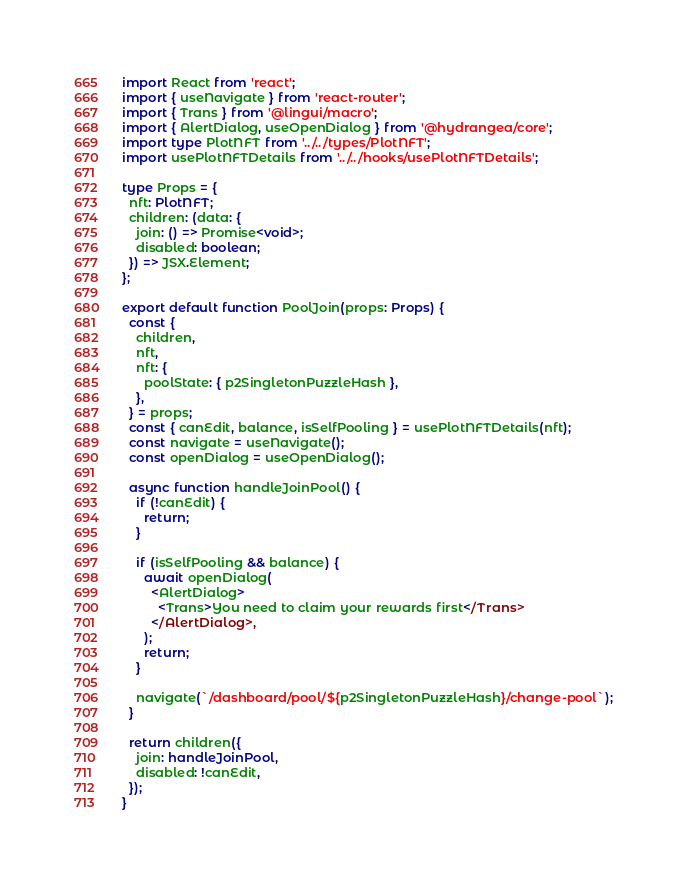<code> <loc_0><loc_0><loc_500><loc_500><_TypeScript_>import React from 'react';
import { useNavigate } from 'react-router';
import { Trans } from '@lingui/macro';
import { AlertDialog, useOpenDialog } from '@hydrangea/core';
import type PlotNFT from '../../types/PlotNFT';
import usePlotNFTDetails from '../../hooks/usePlotNFTDetails';

type Props = {
  nft: PlotNFT;
  children: (data: {
    join: () => Promise<void>;
    disabled: boolean;
  }) => JSX.Element;
};

export default function PoolJoin(props: Props) {
  const {
    children,
    nft,
    nft: {
      poolState: { p2SingletonPuzzleHash },
    },
  } = props;
  const { canEdit, balance, isSelfPooling } = usePlotNFTDetails(nft);
  const navigate = useNavigate();
  const openDialog = useOpenDialog();

  async function handleJoinPool() {
    if (!canEdit) {
      return;
    }

    if (isSelfPooling && balance) {
      await openDialog(
        <AlertDialog>
          <Trans>You need to claim your rewards first</Trans>
        </AlertDialog>,
      );
      return;
    }

    navigate(`/dashboard/pool/${p2SingletonPuzzleHash}/change-pool`);
  }

  return children({
    join: handleJoinPool,
    disabled: !canEdit,
  });
}
</code> 